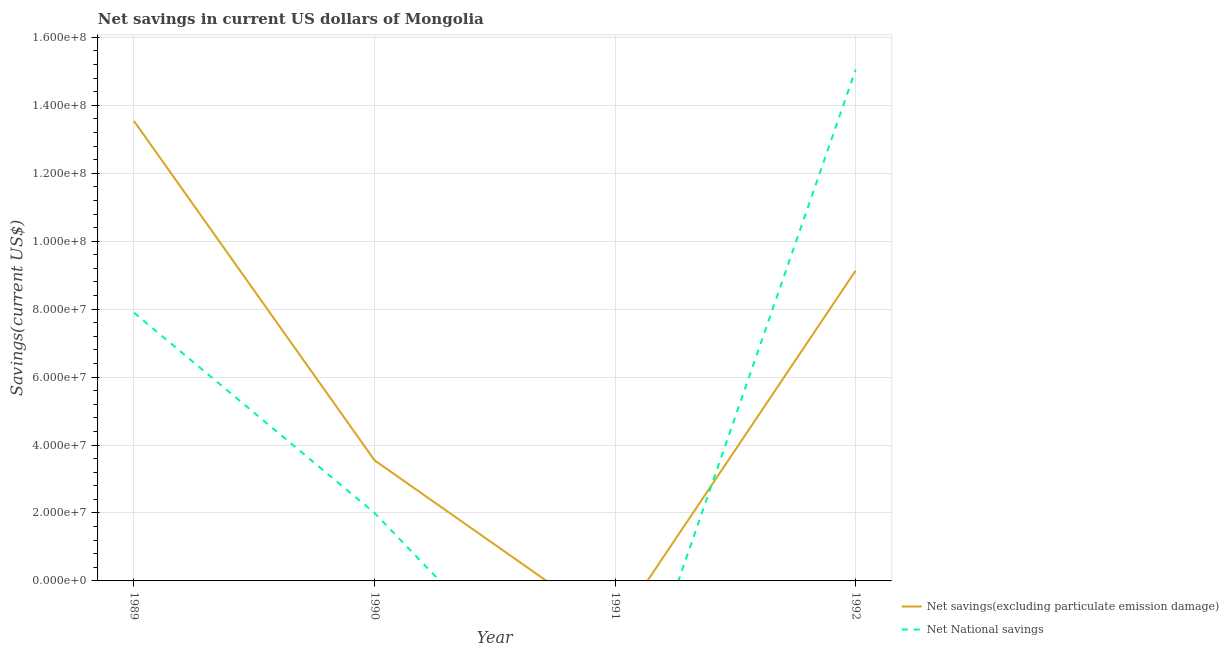Does the line corresponding to net national savings intersect with the line corresponding to net savings(excluding particulate emission damage)?
Provide a short and direct response. Yes. Is the number of lines equal to the number of legend labels?
Provide a short and direct response. No. Across all years, what is the maximum net savings(excluding particulate emission damage)?
Your answer should be compact. 1.35e+08. In which year was the net savings(excluding particulate emission damage) maximum?
Provide a short and direct response. 1989. What is the total net savings(excluding particulate emission damage) in the graph?
Your answer should be compact. 2.62e+08. What is the difference between the net savings(excluding particulate emission damage) in 1989 and that in 1990?
Keep it short and to the point. 9.99e+07. What is the difference between the net savings(excluding particulate emission damage) in 1989 and the net national savings in 1990?
Your response must be concise. 1.15e+08. What is the average net national savings per year?
Give a very brief answer. 6.24e+07. In the year 1992, what is the difference between the net national savings and net savings(excluding particulate emission damage)?
Give a very brief answer. 5.92e+07. In how many years, is the net national savings greater than 60000000 US$?
Your answer should be compact. 2. What is the ratio of the net savings(excluding particulate emission damage) in 1989 to that in 1992?
Offer a terse response. 1.48. Is the net national savings in 1989 less than that in 1992?
Your response must be concise. Yes. Is the difference between the net savings(excluding particulate emission damage) in 1989 and 1990 greater than the difference between the net national savings in 1989 and 1990?
Offer a very short reply. Yes. What is the difference between the highest and the second highest net national savings?
Provide a short and direct response. 7.16e+07. What is the difference between the highest and the lowest net national savings?
Your answer should be compact. 1.51e+08. Is the sum of the net savings(excluding particulate emission damage) in 1990 and 1992 greater than the maximum net national savings across all years?
Provide a succinct answer. No. Does the net national savings monotonically increase over the years?
Provide a short and direct response. No. How many lines are there?
Provide a short and direct response. 2. How many years are there in the graph?
Make the answer very short. 4. What is the difference between two consecutive major ticks on the Y-axis?
Ensure brevity in your answer.  2.00e+07. Does the graph contain grids?
Your answer should be compact. Yes. How many legend labels are there?
Provide a short and direct response. 2. How are the legend labels stacked?
Keep it short and to the point. Vertical. What is the title of the graph?
Make the answer very short. Net savings in current US dollars of Mongolia. Does "Quasi money growth" appear as one of the legend labels in the graph?
Offer a very short reply. No. What is the label or title of the X-axis?
Give a very brief answer. Year. What is the label or title of the Y-axis?
Ensure brevity in your answer.  Savings(current US$). What is the Savings(current US$) of Net savings(excluding particulate emission damage) in 1989?
Your answer should be compact. 1.35e+08. What is the Savings(current US$) in Net National savings in 1989?
Your response must be concise. 7.90e+07. What is the Savings(current US$) in Net savings(excluding particulate emission damage) in 1990?
Ensure brevity in your answer.  3.55e+07. What is the Savings(current US$) in Net National savings in 1990?
Your response must be concise. 2.00e+07. What is the Savings(current US$) of Net National savings in 1991?
Provide a short and direct response. 0. What is the Savings(current US$) of Net savings(excluding particulate emission damage) in 1992?
Provide a succinct answer. 9.14e+07. What is the Savings(current US$) in Net National savings in 1992?
Provide a short and direct response. 1.51e+08. Across all years, what is the maximum Savings(current US$) in Net savings(excluding particulate emission damage)?
Make the answer very short. 1.35e+08. Across all years, what is the maximum Savings(current US$) in Net National savings?
Give a very brief answer. 1.51e+08. What is the total Savings(current US$) in Net savings(excluding particulate emission damage) in the graph?
Your answer should be compact. 2.62e+08. What is the total Savings(current US$) of Net National savings in the graph?
Offer a very short reply. 2.49e+08. What is the difference between the Savings(current US$) in Net savings(excluding particulate emission damage) in 1989 and that in 1990?
Offer a terse response. 9.99e+07. What is the difference between the Savings(current US$) of Net National savings in 1989 and that in 1990?
Your answer should be compact. 5.89e+07. What is the difference between the Savings(current US$) in Net savings(excluding particulate emission damage) in 1989 and that in 1992?
Your answer should be very brief. 4.40e+07. What is the difference between the Savings(current US$) in Net National savings in 1989 and that in 1992?
Offer a terse response. -7.16e+07. What is the difference between the Savings(current US$) in Net savings(excluding particulate emission damage) in 1990 and that in 1992?
Provide a succinct answer. -5.59e+07. What is the difference between the Savings(current US$) in Net National savings in 1990 and that in 1992?
Keep it short and to the point. -1.31e+08. What is the difference between the Savings(current US$) of Net savings(excluding particulate emission damage) in 1989 and the Savings(current US$) of Net National savings in 1990?
Give a very brief answer. 1.15e+08. What is the difference between the Savings(current US$) of Net savings(excluding particulate emission damage) in 1989 and the Savings(current US$) of Net National savings in 1992?
Provide a short and direct response. -1.51e+07. What is the difference between the Savings(current US$) in Net savings(excluding particulate emission damage) in 1990 and the Savings(current US$) in Net National savings in 1992?
Your answer should be compact. -1.15e+08. What is the average Savings(current US$) of Net savings(excluding particulate emission damage) per year?
Provide a succinct answer. 6.56e+07. What is the average Savings(current US$) in Net National savings per year?
Your answer should be very brief. 6.24e+07. In the year 1989, what is the difference between the Savings(current US$) in Net savings(excluding particulate emission damage) and Savings(current US$) in Net National savings?
Ensure brevity in your answer.  5.64e+07. In the year 1990, what is the difference between the Savings(current US$) of Net savings(excluding particulate emission damage) and Savings(current US$) of Net National savings?
Keep it short and to the point. 1.55e+07. In the year 1992, what is the difference between the Savings(current US$) of Net savings(excluding particulate emission damage) and Savings(current US$) of Net National savings?
Your response must be concise. -5.92e+07. What is the ratio of the Savings(current US$) of Net savings(excluding particulate emission damage) in 1989 to that in 1990?
Make the answer very short. 3.81. What is the ratio of the Savings(current US$) of Net National savings in 1989 to that in 1990?
Offer a very short reply. 3.95. What is the ratio of the Savings(current US$) in Net savings(excluding particulate emission damage) in 1989 to that in 1992?
Make the answer very short. 1.48. What is the ratio of the Savings(current US$) of Net National savings in 1989 to that in 1992?
Your answer should be very brief. 0.52. What is the ratio of the Savings(current US$) of Net savings(excluding particulate emission damage) in 1990 to that in 1992?
Provide a short and direct response. 0.39. What is the ratio of the Savings(current US$) in Net National savings in 1990 to that in 1992?
Offer a terse response. 0.13. What is the difference between the highest and the second highest Savings(current US$) in Net savings(excluding particulate emission damage)?
Your answer should be very brief. 4.40e+07. What is the difference between the highest and the second highest Savings(current US$) in Net National savings?
Offer a terse response. 7.16e+07. What is the difference between the highest and the lowest Savings(current US$) in Net savings(excluding particulate emission damage)?
Your answer should be compact. 1.35e+08. What is the difference between the highest and the lowest Savings(current US$) in Net National savings?
Provide a succinct answer. 1.51e+08. 